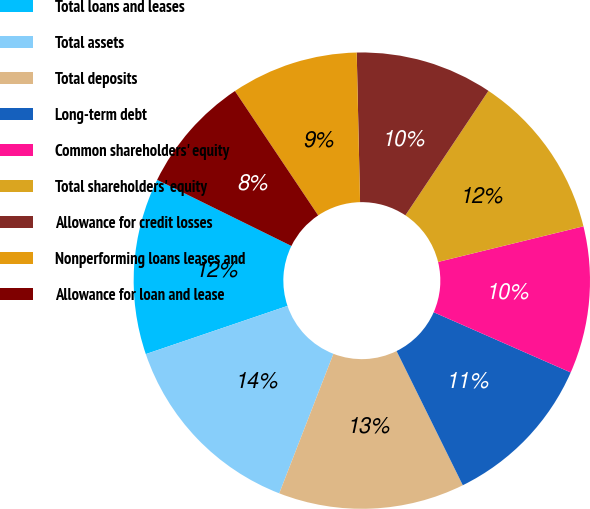Convert chart. <chart><loc_0><loc_0><loc_500><loc_500><pie_chart><fcel>Total loans and leases<fcel>Total assets<fcel>Total deposits<fcel>Long-term debt<fcel>Common shareholders' equity<fcel>Total shareholders' equity<fcel>Allowance for credit losses<fcel>Nonperforming loans leases and<fcel>Allowance for loan and lease<nl><fcel>12.5%<fcel>13.89%<fcel>13.19%<fcel>11.11%<fcel>10.42%<fcel>11.81%<fcel>9.72%<fcel>9.03%<fcel>8.33%<nl></chart> 